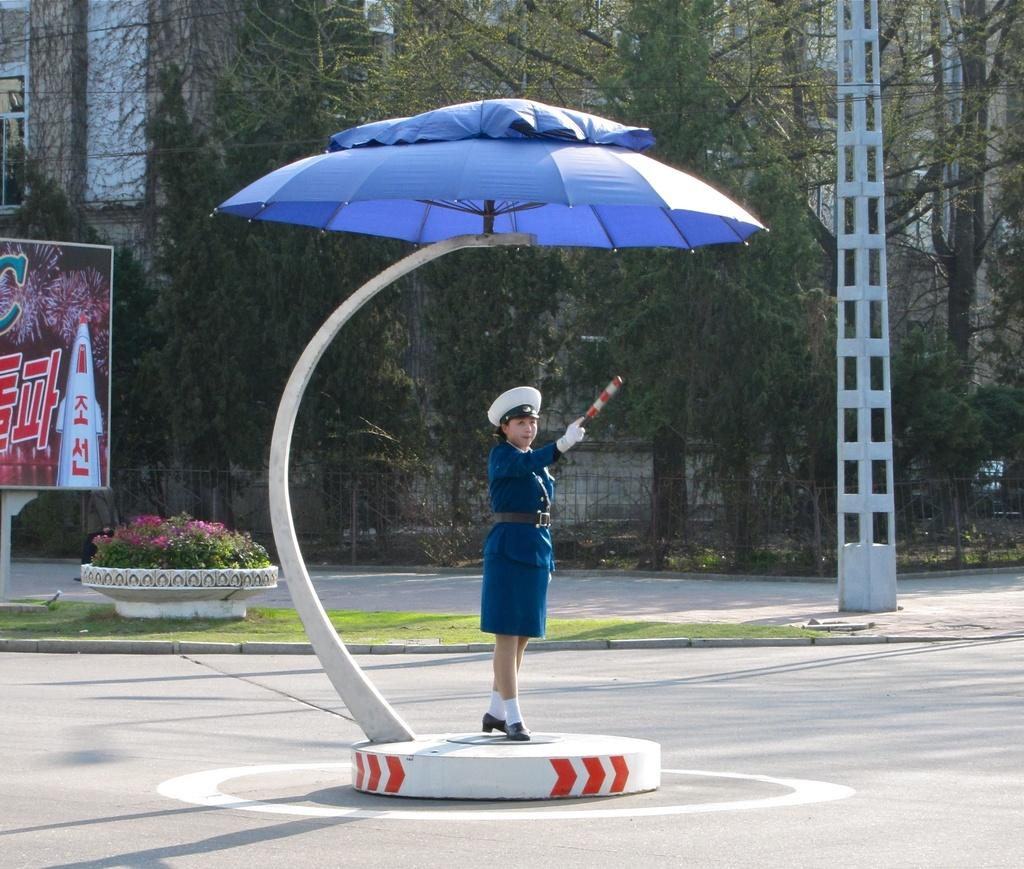What is hanging in the image? There is a banner in the image. What type of vegetation can be seen in the image? There are plants, grass, and trees in the image. Who is present in the image? There is a woman standing in the image. What utility pole can be seen in the image? There is a current pole in the image. What type of structure is visible in the image? There is a building in the image. What is the woman's birth date in the image? There is no information about the woman's birth date in the image. What arithmetic problem is being solved on the banner? There is no arithmetic problem visible on the banner in the image. 